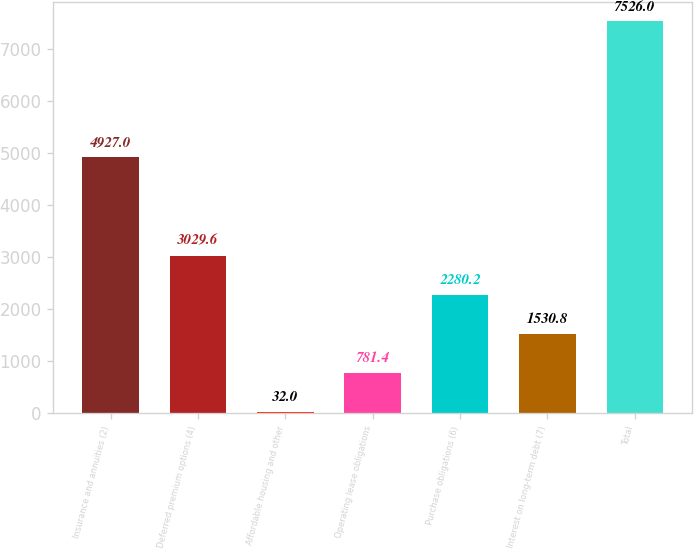Convert chart to OTSL. <chart><loc_0><loc_0><loc_500><loc_500><bar_chart><fcel>Insurance and annuities (2)<fcel>Deferred premium options (4)<fcel>Affordable housing and other<fcel>Operating lease obligations<fcel>Purchase obligations (6)<fcel>Interest on long-term debt (7)<fcel>Total<nl><fcel>4927<fcel>3029.6<fcel>32<fcel>781.4<fcel>2280.2<fcel>1530.8<fcel>7526<nl></chart> 